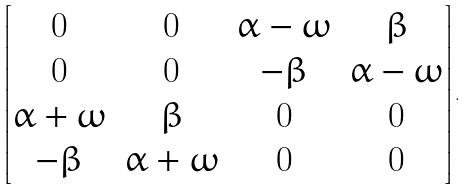<formula> <loc_0><loc_0><loc_500><loc_500>\begin{bmatrix} 0 & 0 & \alpha - \omega & \beta \\ 0 & 0 & - \beta & \alpha - \omega \\ \alpha + \omega & \beta & 0 & 0 \\ - \beta & \alpha + \omega & 0 & 0 \end{bmatrix} .</formula> 